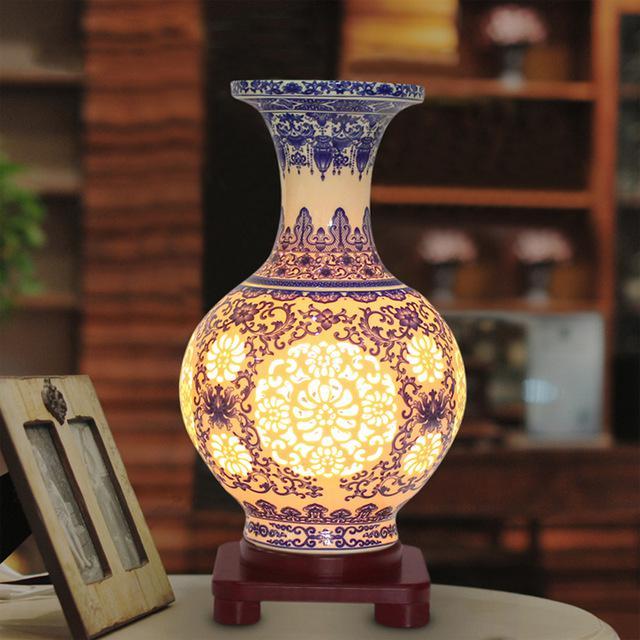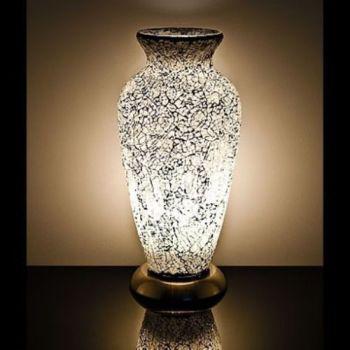The first image is the image on the left, the second image is the image on the right. Assess this claim about the two images: "One of the two vases is glowing yellow.". Correct or not? Answer yes or no. Yes. The first image is the image on the left, the second image is the image on the right. Considering the images on both sides, is "In at least one image  there is a white and black speckled vase with a solid black top and bottom." valid? Answer yes or no. Yes. 